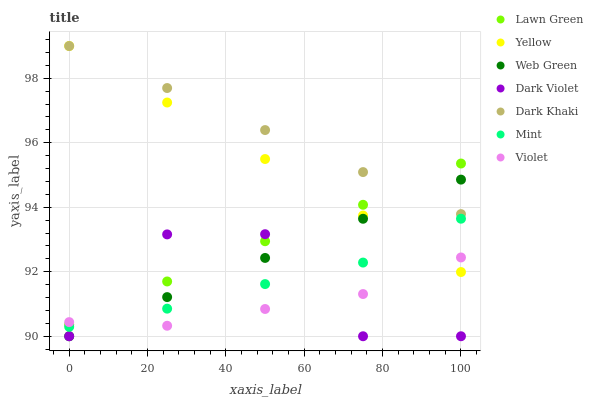Does Violet have the minimum area under the curve?
Answer yes or no. Yes. Does Dark Khaki have the maximum area under the curve?
Answer yes or no. Yes. Does Dark Violet have the minimum area under the curve?
Answer yes or no. No. Does Dark Violet have the maximum area under the curve?
Answer yes or no. No. Is Dark Khaki the smoothest?
Answer yes or no. Yes. Is Dark Violet the roughest?
Answer yes or no. Yes. Is Dark Violet the smoothest?
Answer yes or no. No. Is Dark Khaki the roughest?
Answer yes or no. No. Does Dark Violet have the lowest value?
Answer yes or no. Yes. Does Dark Khaki have the lowest value?
Answer yes or no. No. Does Yellow have the highest value?
Answer yes or no. Yes. Does Dark Violet have the highest value?
Answer yes or no. No. Is Mint less than Lawn Green?
Answer yes or no. Yes. Is Yellow greater than Dark Violet?
Answer yes or no. Yes. Does Dark Khaki intersect Lawn Green?
Answer yes or no. Yes. Is Dark Khaki less than Lawn Green?
Answer yes or no. No. Is Dark Khaki greater than Lawn Green?
Answer yes or no. No. Does Mint intersect Lawn Green?
Answer yes or no. No. 